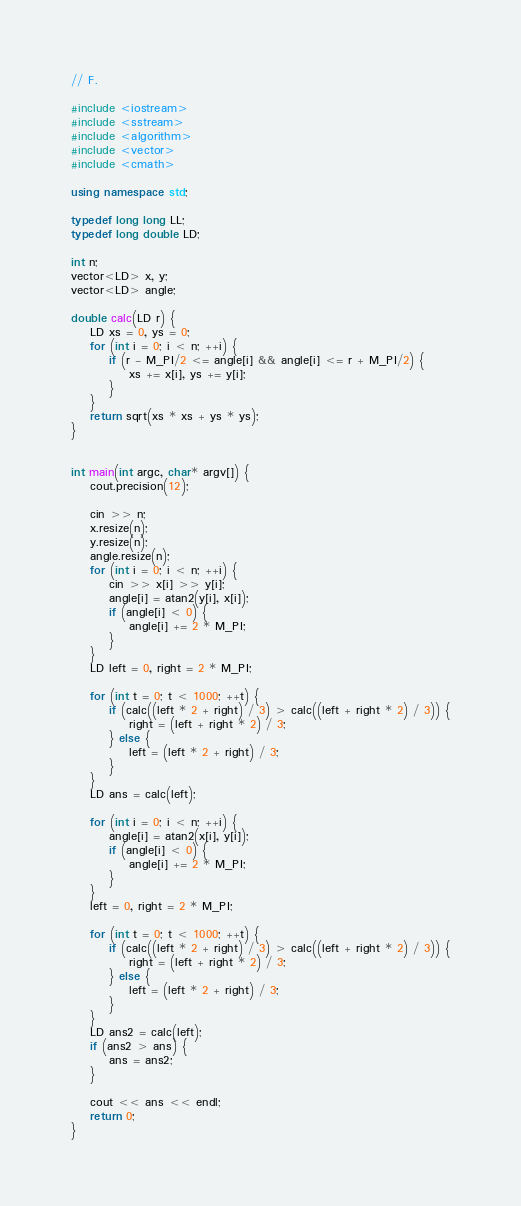<code> <loc_0><loc_0><loc_500><loc_500><_C++_>// F.

#include <iostream>
#include <sstream>
#include <algorithm>
#include <vector>
#include <cmath>

using namespace std;

typedef long long LL;
typedef long double LD;

int n;
vector<LD> x, y;
vector<LD> angle;

double calc(LD r) {
	LD xs = 0, ys = 0;
	for (int i = 0; i < n; ++i) {
		if (r - M_PI/2 <= angle[i] && angle[i] <= r + M_PI/2) {
			xs += x[i], ys += y[i];
		}
	}
	return sqrt(xs * xs + ys * ys);
}


int main(int argc, char* argv[]) {
	cout.precision(12);

	cin >> n;
	x.resize(n);
	y.resize(n);
	angle.resize(n);
	for (int i = 0; i < n; ++i) {
		cin >> x[i] >> y[i];
		angle[i] = atan2(y[i], x[i]);
		if (angle[i] < 0) {
			angle[i] += 2 * M_PI;
		}
	}
	LD left = 0, right = 2 * M_PI;

	for (int t = 0; t < 1000; ++t) {
		if (calc((left * 2 + right) / 3) > calc((left + right * 2) / 3)) {
			right = (left + right * 2) / 3;
		} else {
			left = (left * 2 + right) / 3;
		}
	}
	LD ans = calc(left);

	for (int i = 0; i < n; ++i) {
		angle[i] = atan2(x[i], y[i]);
		if (angle[i] < 0) {
			angle[i] += 2 * M_PI;
		}
	}
	left = 0, right = 2 * M_PI;

	for (int t = 0; t < 1000; ++t) {
		if (calc((left * 2 + right) / 3) > calc((left + right * 2) / 3)) {
			right = (left + right * 2) / 3;
		} else {
			left = (left * 2 + right) / 3;
		}
	}
	LD ans2 = calc(left);
	if (ans2 > ans) {
		ans = ans2;
	}

	cout << ans << endl;
	return 0;
}
</code> 